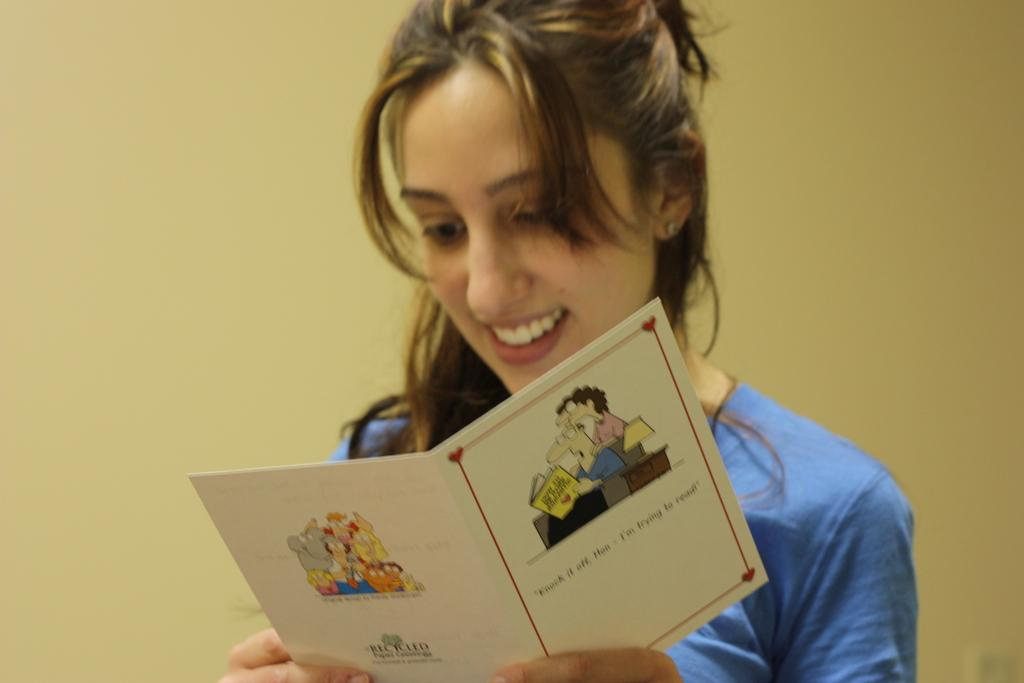Who is present in the image? There is a woman in the image. What is the woman holding in the image? The woman is holding a greeting card. What can be seen behind the woman in the image? There is a wall behind the woman. What type of guide is the woman using to find her way in the image? There is no guide present in the image, as the woman is holding a greeting card. 